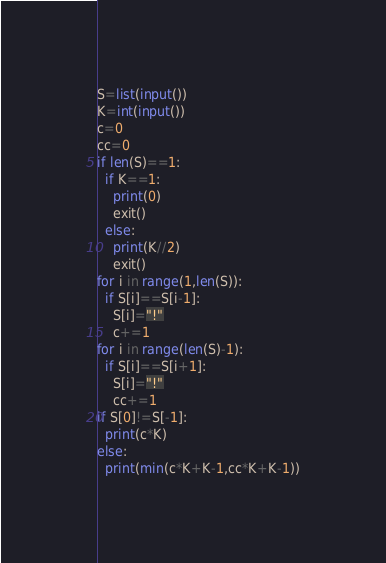<code> <loc_0><loc_0><loc_500><loc_500><_Python_>S=list(input())
K=int(input())
c=0
cc=0
if len(S)==1:
  if K==1:
    print(0)
    exit()
  else:
    print(K//2)
    exit()
for i in range(1,len(S)):
  if S[i]==S[i-1]:
    S[i]="!"
    c+=1
for i in range(len(S)-1):
  if S[i]==S[i+1]:
    S[i]="!"
    cc+=1
if S[0]!=S[-1]:
  print(c*K)
else:
  print(min(c*K+K-1,cc*K+K-1))</code> 